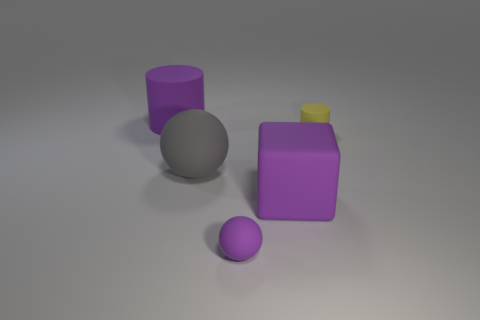Is the yellow cylinder made of the same material as the tiny thing in front of the small yellow thing?
Make the answer very short. Yes. The tiny thing that is to the right of the big purple matte object to the right of the big purple matte cylinder is made of what material?
Offer a terse response. Rubber. Is the number of small spheres that are to the right of the purple matte sphere greater than the number of big brown metallic blocks?
Your answer should be very brief. No. Is there a rubber cylinder?
Your answer should be compact. Yes. There is a thing that is in front of the purple rubber block; what color is it?
Your answer should be compact. Purple. There is a purple ball that is the same size as the yellow cylinder; what material is it?
Your response must be concise. Rubber. What number of other objects are the same material as the purple cylinder?
Your response must be concise. 4. The object that is in front of the gray rubber sphere and behind the small purple thing is what color?
Make the answer very short. Purple. How many things are purple things that are right of the large cylinder or big matte blocks?
Give a very brief answer. 2. What number of other things are there of the same color as the large cylinder?
Offer a terse response. 2. 